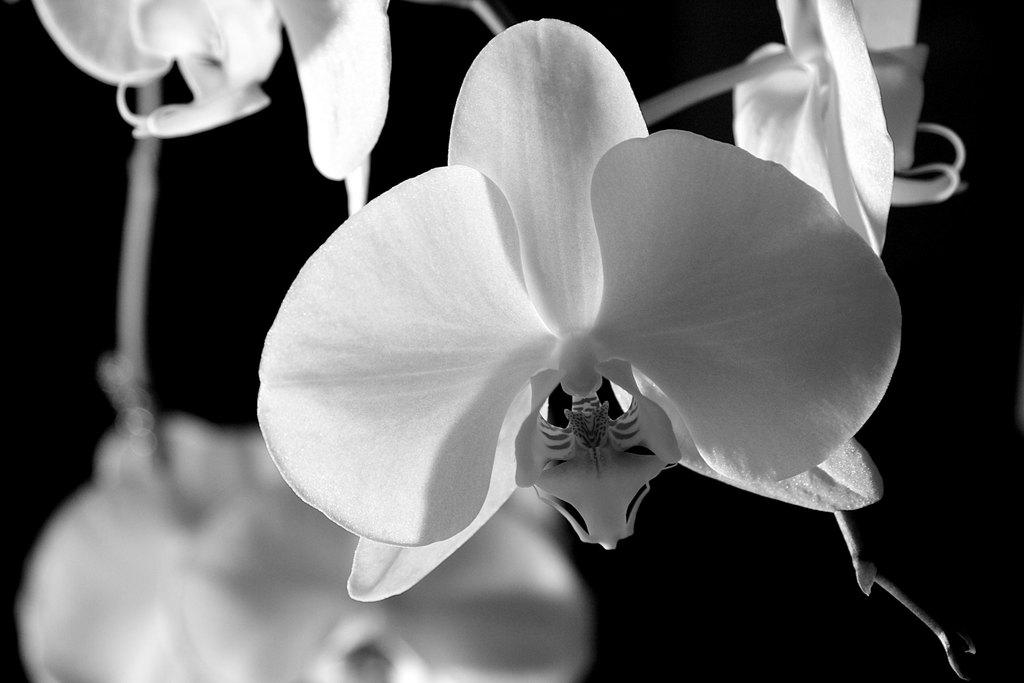What is the color scheme of the image? The image is black and white. What color are the objects in the image? The objects in the image are white. What color is the background of the image? The background of the image is black. Are there any parts of the image that are not clear? Yes, the image is blurred in some parts. What type of channel can be seen in the image? There is no channel present in the image; it is a black and white image with white objects and a black background. Is there a brother in the image? There is no person or figure in the image, so there is no brother present. 